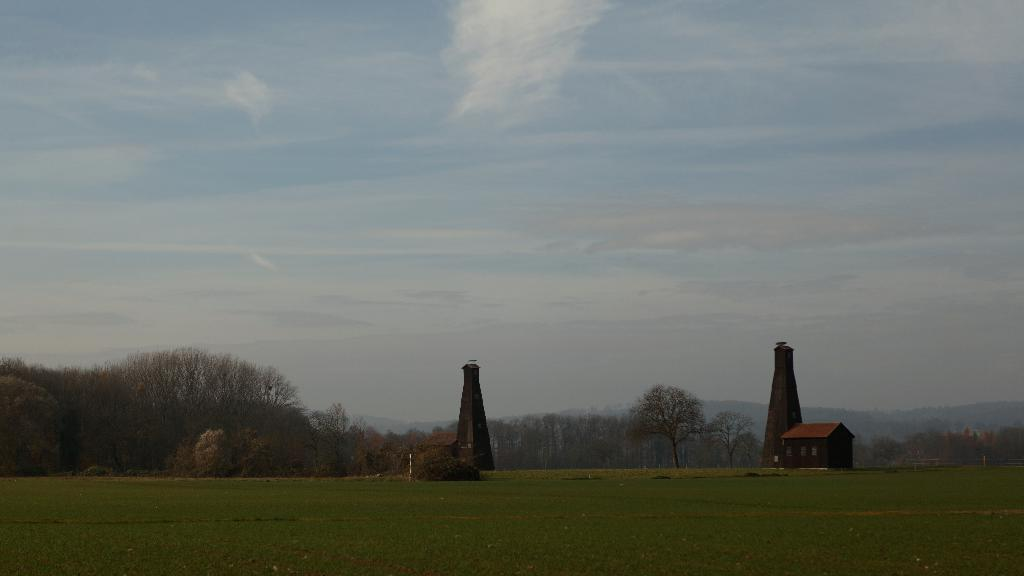What type of terrain is visible in the image? There is grassy land in the image. What natural elements can be seen in the image? There are trees and plants in the image. What man-made structures are present in the image? There are towers and a house in the image. What is visible at the top of the image? The sky is visible at the top of the image. What can be seen in the sky? Clouds are present in the sky. Can you provide an example of a snake in the image? There are no snakes present in the image. 